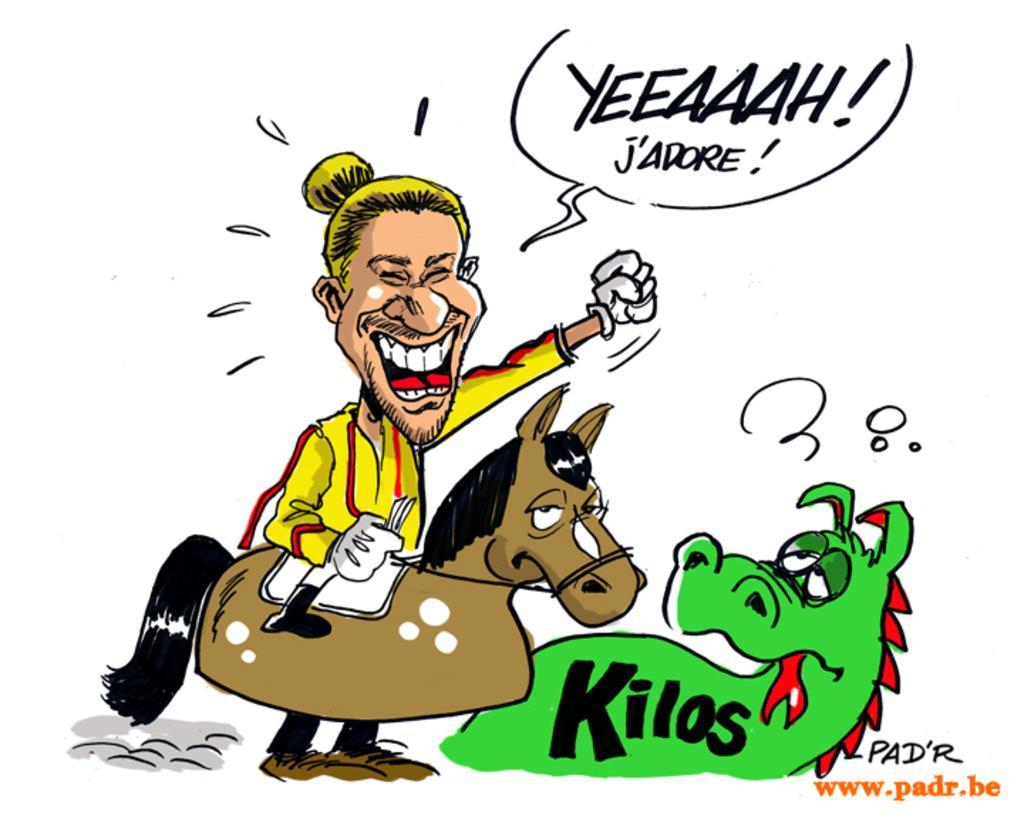Could you give a brief overview of what you see in this image? In this image, we can see depiction of a person, animals and some text on the white background. 